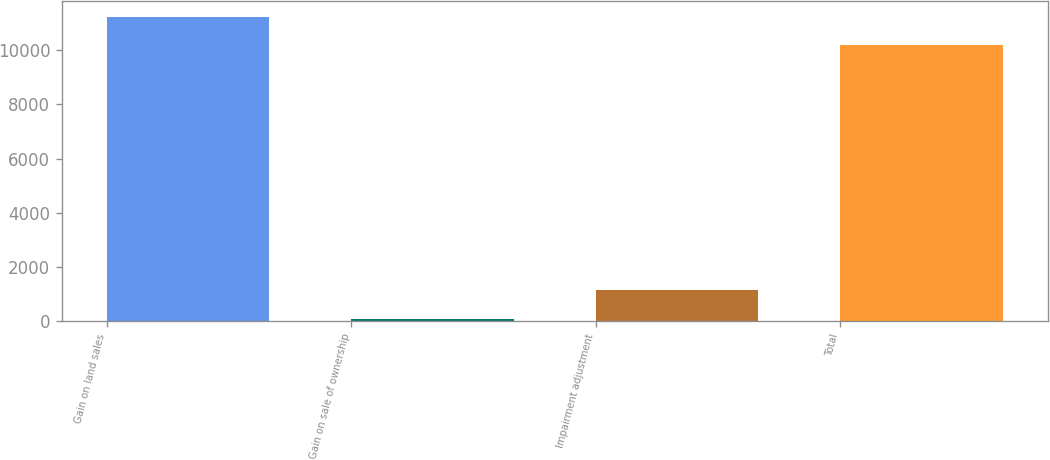Convert chart. <chart><loc_0><loc_0><loc_500><loc_500><bar_chart><fcel>Gain on land sales<fcel>Gain on sale of ownership<fcel>Impairment adjustment<fcel>Total<nl><fcel>11248<fcel>83<fcel>1129<fcel>10202<nl></chart> 